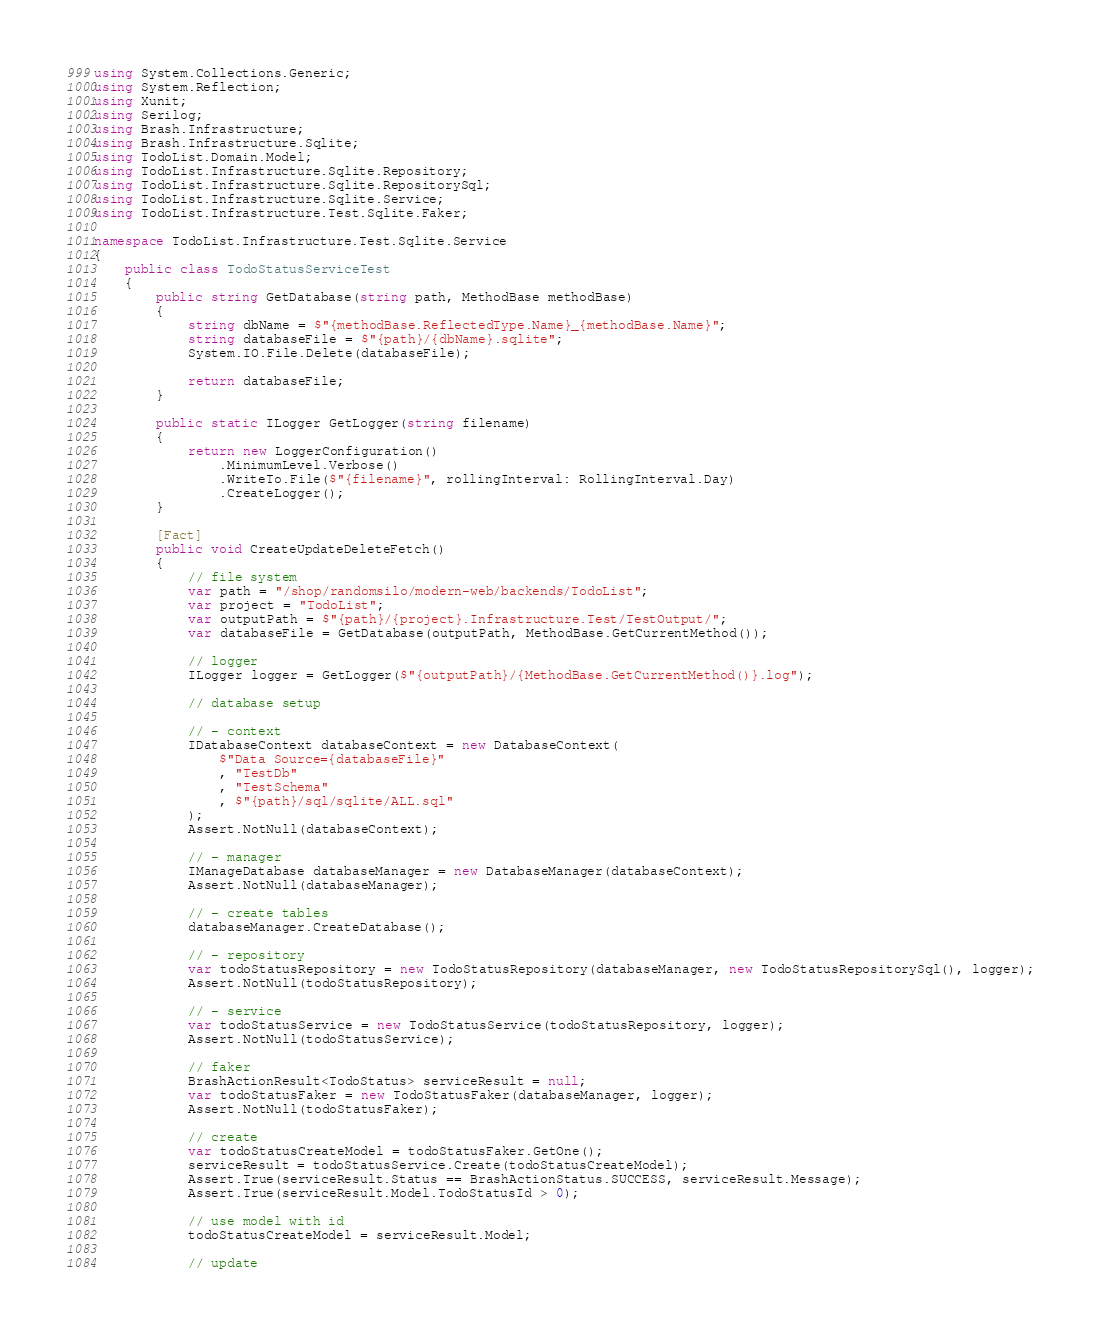Convert code to text. <code><loc_0><loc_0><loc_500><loc_500><_C#_>
using System.Collections.Generic;
using System.Reflection;
using Xunit;
using Serilog;
using Brash.Infrastructure;
using Brash.Infrastructure.Sqlite;
using TodoList.Domain.Model;
using TodoList.Infrastructure.Sqlite.Repository;
using TodoList.Infrastructure.Sqlite.RepositorySql;
using TodoList.Infrastructure.Sqlite.Service;
using TodoList.Infrastructure.Test.Sqlite.Faker;

namespace TodoList.Infrastructure.Test.Sqlite.Service
{
	public class TodoStatusServiceTest
	{
		public string GetDatabase(string path, MethodBase methodBase)
		{
			string dbName = $"{methodBase.ReflectedType.Name}_{methodBase.Name}";
			string databaseFile = $"{path}/{dbName}.sqlite";
			System.IO.File.Delete(databaseFile);

			return databaseFile;
		}

		public static ILogger GetLogger(string filename)
		{
			return new LoggerConfiguration()
				.MinimumLevel.Verbose()
				.WriteTo.File($"{filename}", rollingInterval: RollingInterval.Day)
				.CreateLogger();
		}

		[Fact]
		public void CreateUpdateDeleteFetch()
		{
			// file system
			var path = "/shop/randomsilo/modern-web/backends/TodoList";
			var project = "TodoList";
			var outputPath = $"{path}/{project}.Infrastructure.Test/TestOutput/";
			var databaseFile = GetDatabase(outputPath, MethodBase.GetCurrentMethod());
			
			// logger
			ILogger logger = GetLogger($"{outputPath}/{MethodBase.GetCurrentMethod()}.log");
			
			// database setup

			// - context
			IDatabaseContext databaseContext = new DatabaseContext(
				$"Data Source={databaseFile}" 
				, "TestDb"
				, "TestSchema"
				, $"{path}/sql/sqlite/ALL.sql"
			);
			Assert.NotNull(databaseContext);

			// - manager
			IManageDatabase databaseManager = new DatabaseManager(databaseContext);
			Assert.NotNull(databaseManager);

			// - create tables
			databaseManager.CreateDatabase();

			// - repository
			var todoStatusRepository = new TodoStatusRepository(databaseManager, new TodoStatusRepositorySql(), logger);
			Assert.NotNull(todoStatusRepository);

			// - service
			var todoStatusService = new TodoStatusService(todoStatusRepository, logger);
			Assert.NotNull(todoStatusService);

			// faker
			BrashActionResult<TodoStatus> serviceResult = null;
			var todoStatusFaker = new TodoStatusFaker(databaseManager, logger);
			Assert.NotNull(todoStatusFaker);

			// create
			var todoStatusCreateModel = todoStatusFaker.GetOne();
			serviceResult = todoStatusService.Create(todoStatusCreateModel);
			Assert.True(serviceResult.Status == BrashActionStatus.SUCCESS, serviceResult.Message);
			Assert.True(serviceResult.Model.TodoStatusId > 0);

			// use model with id
			todoStatusCreateModel = serviceResult.Model;

			// update</code> 